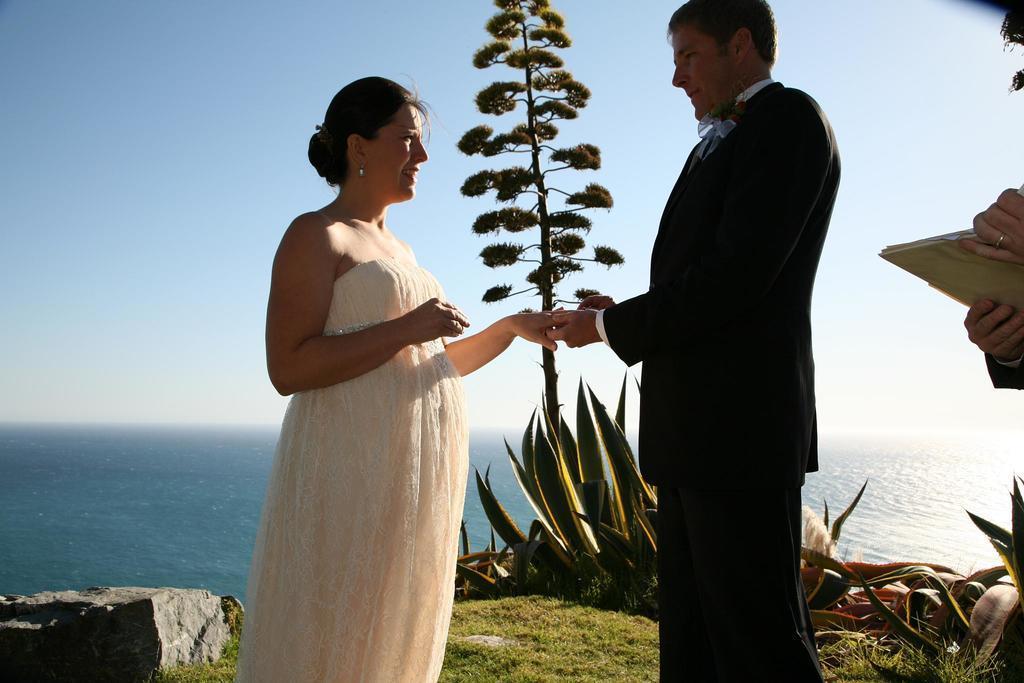In one or two sentences, can you explain what this image depicts? Here we can see a woman and a man standing on the grass. He is holding a hand of her. There are plants, rock, and a tree. This is water. In the background there is sky. 